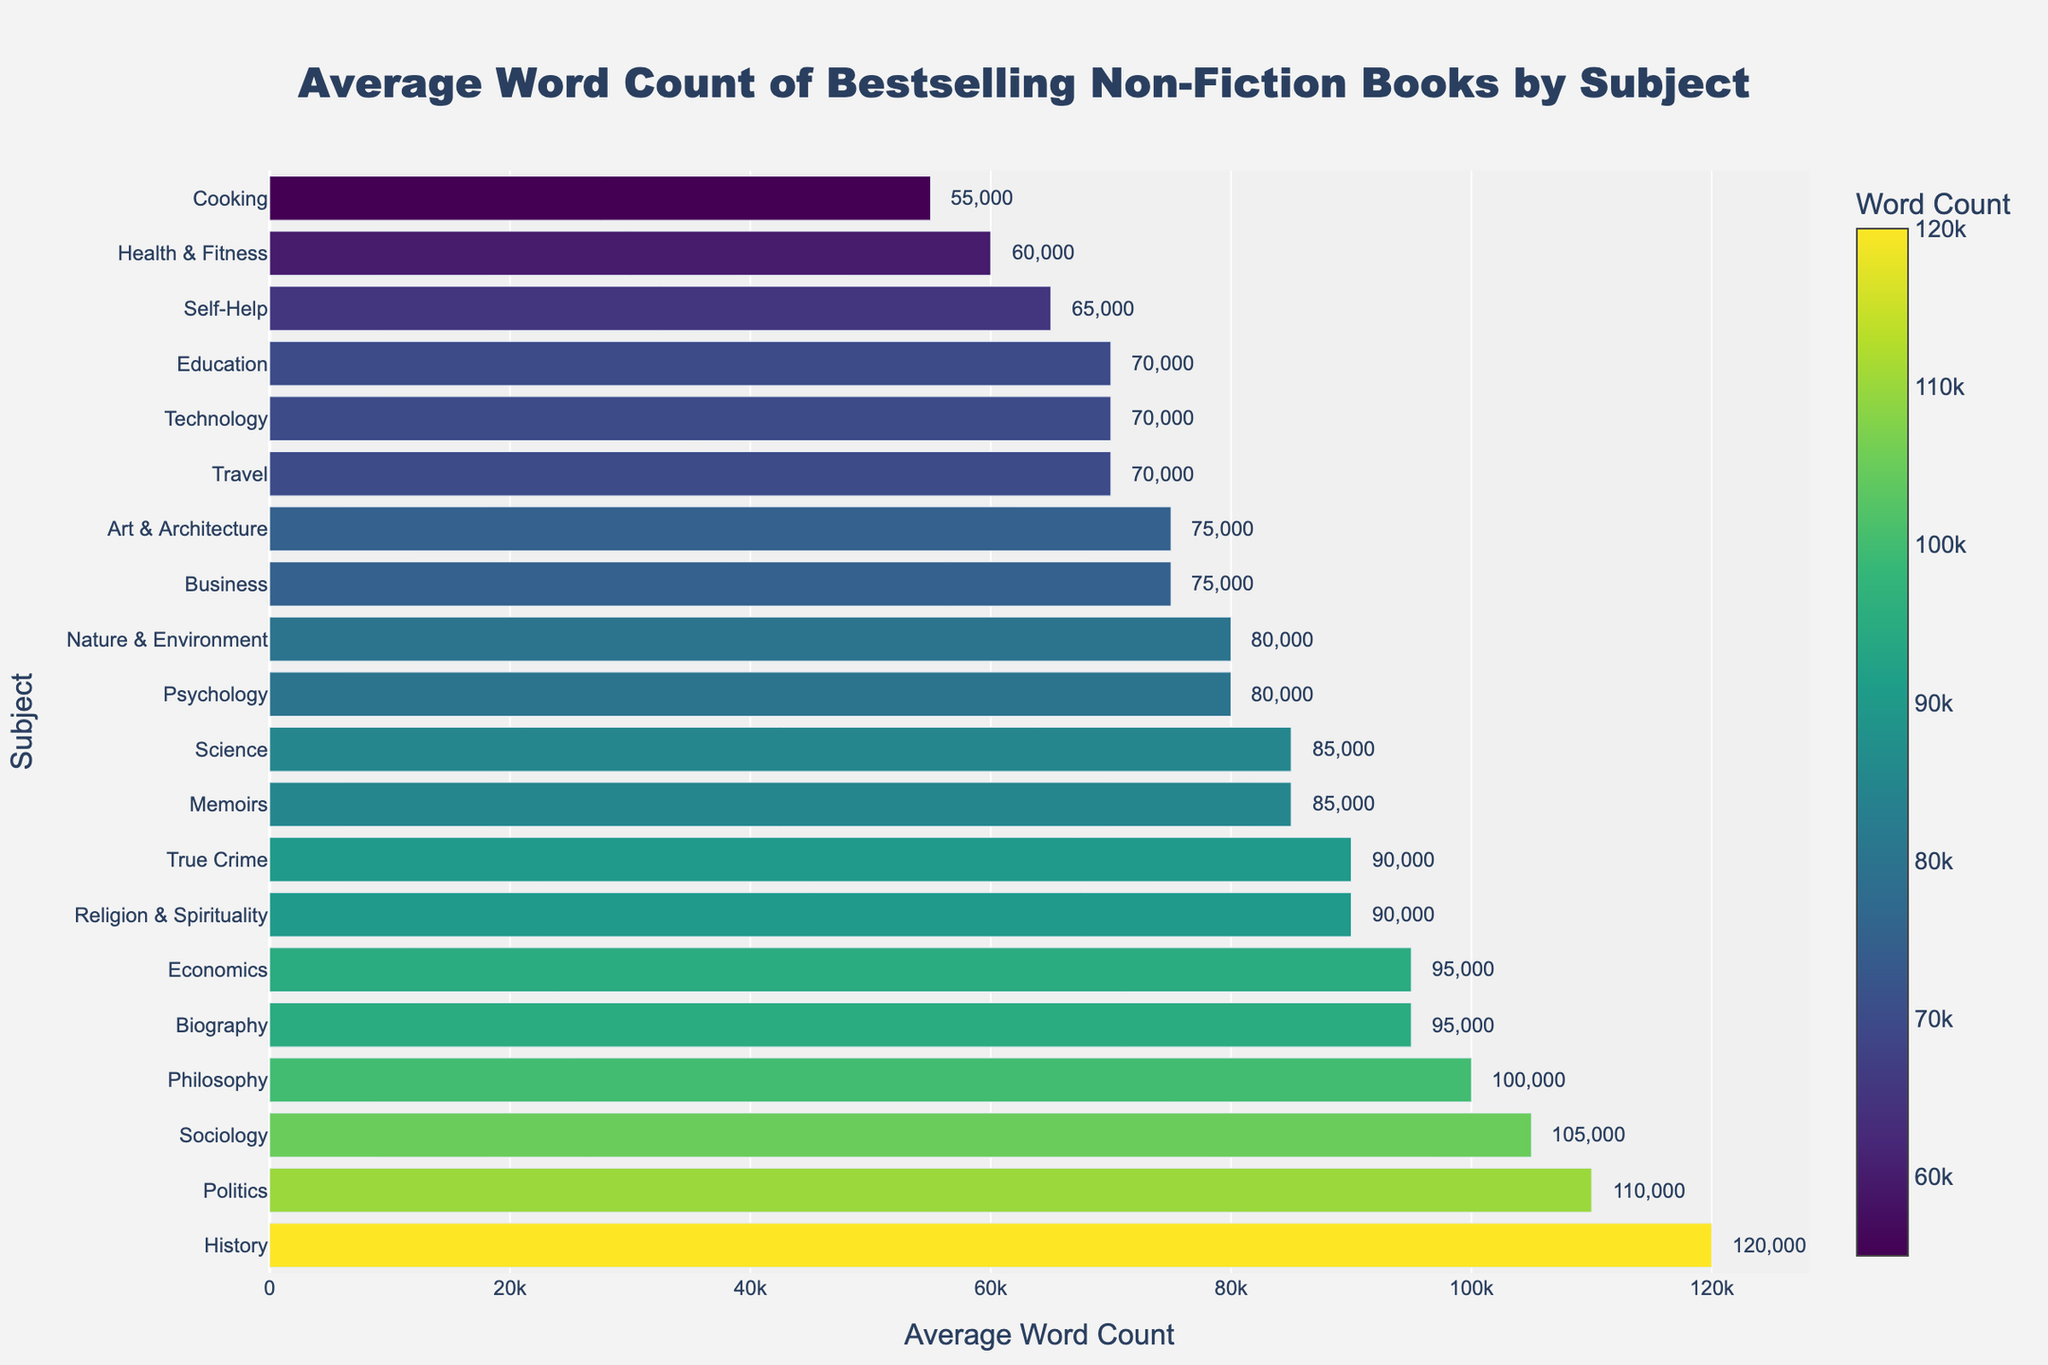Which subject has the highest average word count? Look at the bar corresponding to the longest bar. The longest bar represents "History" with 120,000 words.
Answer: History What's the difference in average word count between the subject with the highest and the lowest word count? The highest average word count is for "History" with 120,000 words and the lowest is for "Cooking" with 55,000 words. The difference is 120,000 - 55,000 = 65,000.
Answer: 65,000 Which subjects have an average word count greater than 100,000? Find bars with lengths greater than 100,000. The subjects are "History" (120,000), "Philosophy" (100,000), "Politics" (110,000), and "Sociology" (105,000).
Answer: History, Philosophy, Politics, Sociology By how much does the average word count for "Biography" exceed "Self-Help"? The average word count for "Biography" is 95,000 and for "Self-Help" is 65,000. The difference is 95,000 - 65,000 = 30,000.
Answer: 30,000 How does the average word count for "True Crime" compare to "Religion & Spirituality"? Both "True Crime" and "Religion & Spirituality" have the same average word count, which is 90,000.
Answer: Equal What is the combined average word count for "Business" and "Art & Architecture"? The average word count for "Business" is 75,000 and for "Art & Architecture" is 75,000. The combined word count is 75,000 + 75,000 = 150,000.
Answer: 150,000 What is the median average word count among all subjects? To find the median, list all the word counts in ascending order (55,000, 60,000, 65,000, 70,000, 70,000, 70,000, 75,000, 75,000, 80,000, 80,000, 85,000, 85,000, 90,000, 90,000, 95,000, 95,000, 100,000, 105,000, 110,000, 120,000). The median value is between the 10th and 11th values: (80,000 + 85,000) / 2 = 82,500.
Answer: 82,500 Which subjects have an average word count close to 70,000? The bars that approximate 70,000 are for "Travel", "Education", and "Technology".
Answer: Travel, Education, Technology What color represents bars with average word counts less than 60,000? The color of the shortest bar, representing "Cooking" with 55,000 words, is part of a light green color spectrum.
Answer: Light green How much lower is the average word count for "Self-Help" compared to "Philosophy"? The average word count for "Self-Help" is 65,000 and for "Philosophy" is 100,000. The difference is 100,000 - 65,000 = 35,000.
Answer: 35,000 